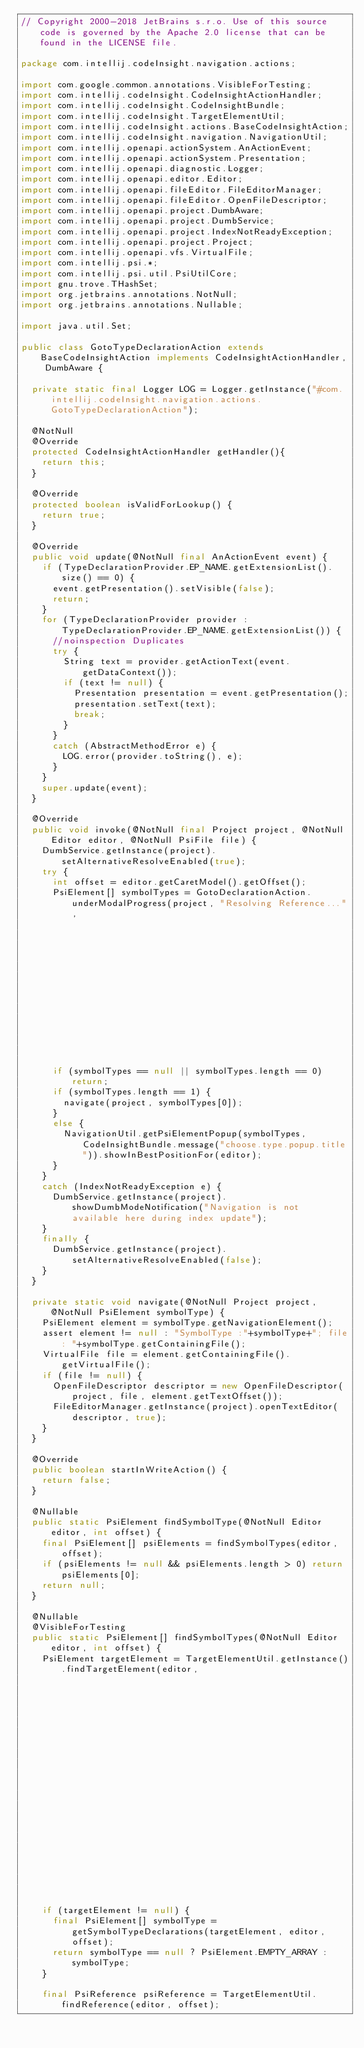Convert code to text. <code><loc_0><loc_0><loc_500><loc_500><_Java_>// Copyright 2000-2018 JetBrains s.r.o. Use of this source code is governed by the Apache 2.0 license that can be found in the LICENSE file.

package com.intellij.codeInsight.navigation.actions;

import com.google.common.annotations.VisibleForTesting;
import com.intellij.codeInsight.CodeInsightActionHandler;
import com.intellij.codeInsight.CodeInsightBundle;
import com.intellij.codeInsight.TargetElementUtil;
import com.intellij.codeInsight.actions.BaseCodeInsightAction;
import com.intellij.codeInsight.navigation.NavigationUtil;
import com.intellij.openapi.actionSystem.AnActionEvent;
import com.intellij.openapi.actionSystem.Presentation;
import com.intellij.openapi.diagnostic.Logger;
import com.intellij.openapi.editor.Editor;
import com.intellij.openapi.fileEditor.FileEditorManager;
import com.intellij.openapi.fileEditor.OpenFileDescriptor;
import com.intellij.openapi.project.DumbAware;
import com.intellij.openapi.project.DumbService;
import com.intellij.openapi.project.IndexNotReadyException;
import com.intellij.openapi.project.Project;
import com.intellij.openapi.vfs.VirtualFile;
import com.intellij.psi.*;
import com.intellij.psi.util.PsiUtilCore;
import gnu.trove.THashSet;
import org.jetbrains.annotations.NotNull;
import org.jetbrains.annotations.Nullable;

import java.util.Set;

public class GotoTypeDeclarationAction extends BaseCodeInsightAction implements CodeInsightActionHandler, DumbAware {

  private static final Logger LOG = Logger.getInstance("#com.intellij.codeInsight.navigation.actions.GotoTypeDeclarationAction");

  @NotNull
  @Override
  protected CodeInsightActionHandler getHandler(){
    return this;
  }

  @Override
  protected boolean isValidForLookup() {
    return true;
  }

  @Override
  public void update(@NotNull final AnActionEvent event) {
    if (TypeDeclarationProvider.EP_NAME.getExtensionList().size() == 0) {
      event.getPresentation().setVisible(false);
      return;
    }
    for (TypeDeclarationProvider provider : TypeDeclarationProvider.EP_NAME.getExtensionList()) {
      //noinspection Duplicates
      try {
        String text = provider.getActionText(event.getDataContext());
        if (text != null) {
          Presentation presentation = event.getPresentation();
          presentation.setText(text);
          break;
        }
      }
      catch (AbstractMethodError e) {
        LOG.error(provider.toString(), e);
      }
    }
    super.update(event);
  }

  @Override
  public void invoke(@NotNull final Project project, @NotNull Editor editor, @NotNull PsiFile file) {
    DumbService.getInstance(project).setAlternativeResolveEnabled(true);
    try {
      int offset = editor.getCaretModel().getOffset();
      PsiElement[] symbolTypes = GotoDeclarationAction.underModalProgress(project, "Resolving Reference...",
                                                                          () -> findSymbolTypes(editor, offset));
      if (symbolTypes == null || symbolTypes.length == 0) return;
      if (symbolTypes.length == 1) {
        navigate(project, symbolTypes[0]);
      }
      else {
        NavigationUtil.getPsiElementPopup(symbolTypes, CodeInsightBundle.message("choose.type.popup.title")).showInBestPositionFor(editor);
      }
    }
    catch (IndexNotReadyException e) {
      DumbService.getInstance(project).showDumbModeNotification("Navigation is not available here during index update");
    }
    finally {
      DumbService.getInstance(project).setAlternativeResolveEnabled(false);
    }
  }

  private static void navigate(@NotNull Project project, @NotNull PsiElement symbolType) {
    PsiElement element = symbolType.getNavigationElement();
    assert element != null : "SymbolType :"+symbolType+"; file: "+symbolType.getContainingFile();
    VirtualFile file = element.getContainingFile().getVirtualFile();
    if (file != null) {
      OpenFileDescriptor descriptor = new OpenFileDescriptor(project, file, element.getTextOffset());
      FileEditorManager.getInstance(project).openTextEditor(descriptor, true);
    }
  }

  @Override
  public boolean startInWriteAction() {
    return false;
  }

  @Nullable
  public static PsiElement findSymbolType(@NotNull Editor editor, int offset) {
    final PsiElement[] psiElements = findSymbolTypes(editor, offset);
    if (psiElements != null && psiElements.length > 0) return psiElements[0];
    return null;
  }

  @Nullable
  @VisibleForTesting
  public static PsiElement[] findSymbolTypes(@NotNull Editor editor, int offset) {
    PsiElement targetElement = TargetElementUtil.getInstance().findTargetElement(editor,
                                                                                     TargetElementUtil.REFERENCED_ELEMENT_ACCEPTED |
                                                                                     TargetElementUtil.ELEMENT_NAME_ACCEPTED |
                                                                                     TargetElementUtil.LOOKUP_ITEM_ACCEPTED,
                                                                                     offset);

    if (targetElement != null) {
      final PsiElement[] symbolType = getSymbolTypeDeclarations(targetElement, editor, offset);
      return symbolType == null ? PsiElement.EMPTY_ARRAY : symbolType;
    }

    final PsiReference psiReference = TargetElementUtil.findReference(editor, offset);</code> 